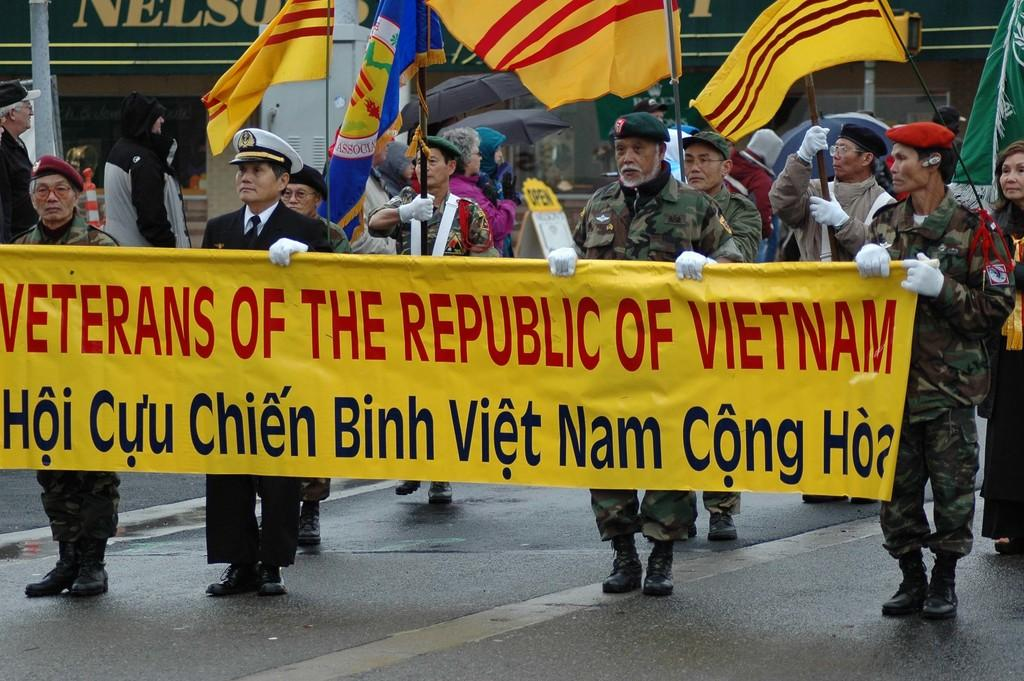What are the people in the image doing? There is a group of people standing on the road. What are the people holding in their hands? The people are holding yellow color cloth with their hands. Can you describe the background of the image? There are people holding flags in the background. What type of quill can be seen in the hands of the people in the image? There is no quill present in the image; the people are holding yellow color cloth. What kind of plant is growing in the hands of the people in the image? There is no plant present in the image; the people are holding yellow color cloth. 